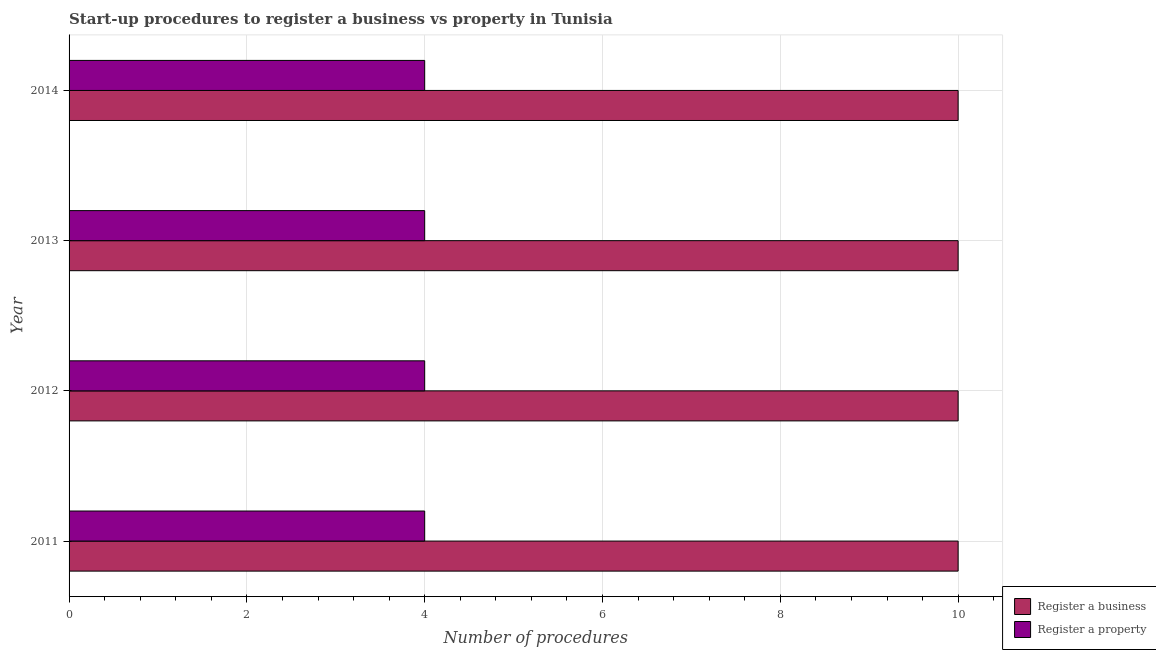Are the number of bars on each tick of the Y-axis equal?
Ensure brevity in your answer.  Yes. How many bars are there on the 3rd tick from the bottom?
Your answer should be compact. 2. In how many cases, is the number of bars for a given year not equal to the number of legend labels?
Ensure brevity in your answer.  0. What is the number of procedures to register a property in 2014?
Provide a short and direct response. 4. Across all years, what is the maximum number of procedures to register a business?
Give a very brief answer. 10. Across all years, what is the minimum number of procedures to register a property?
Offer a very short reply. 4. What is the total number of procedures to register a property in the graph?
Offer a very short reply. 16. What is the difference between the number of procedures to register a property in 2012 and the number of procedures to register a business in 2014?
Offer a very short reply. -6. Is the difference between the number of procedures to register a property in 2013 and 2014 greater than the difference between the number of procedures to register a business in 2013 and 2014?
Your answer should be compact. No. What is the difference between the highest and the lowest number of procedures to register a business?
Offer a terse response. 0. Is the sum of the number of procedures to register a property in 2012 and 2013 greater than the maximum number of procedures to register a business across all years?
Your answer should be compact. No. What does the 2nd bar from the top in 2014 represents?
Ensure brevity in your answer.  Register a business. What does the 2nd bar from the bottom in 2013 represents?
Your response must be concise. Register a property. How many bars are there?
Offer a terse response. 8. Are all the bars in the graph horizontal?
Your answer should be compact. Yes. How many years are there in the graph?
Your answer should be very brief. 4. What is the difference between two consecutive major ticks on the X-axis?
Your response must be concise. 2. Does the graph contain grids?
Give a very brief answer. Yes. How are the legend labels stacked?
Your response must be concise. Vertical. What is the title of the graph?
Your answer should be compact. Start-up procedures to register a business vs property in Tunisia. Does "Net National savings" appear as one of the legend labels in the graph?
Your answer should be compact. No. What is the label or title of the X-axis?
Your answer should be very brief. Number of procedures. What is the Number of procedures of Register a property in 2011?
Your response must be concise. 4. What is the Number of procedures in Register a property in 2012?
Your response must be concise. 4. What is the Number of procedures in Register a business in 2013?
Ensure brevity in your answer.  10. What is the Number of procedures of Register a property in 2014?
Your answer should be compact. 4. Across all years, what is the maximum Number of procedures of Register a property?
Provide a succinct answer. 4. Across all years, what is the minimum Number of procedures in Register a business?
Give a very brief answer. 10. Across all years, what is the minimum Number of procedures of Register a property?
Provide a succinct answer. 4. What is the total Number of procedures of Register a business in the graph?
Provide a succinct answer. 40. What is the total Number of procedures in Register a property in the graph?
Keep it short and to the point. 16. What is the difference between the Number of procedures of Register a property in 2011 and that in 2012?
Provide a short and direct response. 0. What is the difference between the Number of procedures in Register a business in 2011 and that in 2013?
Ensure brevity in your answer.  0. What is the difference between the Number of procedures in Register a property in 2011 and that in 2013?
Offer a very short reply. 0. What is the difference between the Number of procedures in Register a business in 2011 and that in 2014?
Provide a succinct answer. 0. What is the difference between the Number of procedures of Register a property in 2011 and that in 2014?
Keep it short and to the point. 0. What is the difference between the Number of procedures of Register a property in 2012 and that in 2014?
Provide a short and direct response. 0. What is the difference between the Number of procedures in Register a property in 2013 and that in 2014?
Make the answer very short. 0. What is the difference between the Number of procedures in Register a business in 2011 and the Number of procedures in Register a property in 2012?
Provide a short and direct response. 6. What is the difference between the Number of procedures of Register a business in 2011 and the Number of procedures of Register a property in 2014?
Offer a very short reply. 6. What is the difference between the Number of procedures in Register a business in 2012 and the Number of procedures in Register a property in 2014?
Ensure brevity in your answer.  6. What is the difference between the Number of procedures in Register a business in 2013 and the Number of procedures in Register a property in 2014?
Your response must be concise. 6. What is the average Number of procedures in Register a property per year?
Your answer should be very brief. 4. In the year 2012, what is the difference between the Number of procedures of Register a business and Number of procedures of Register a property?
Provide a succinct answer. 6. In the year 2014, what is the difference between the Number of procedures in Register a business and Number of procedures in Register a property?
Make the answer very short. 6. What is the ratio of the Number of procedures in Register a business in 2011 to that in 2012?
Ensure brevity in your answer.  1. What is the ratio of the Number of procedures of Register a property in 2011 to that in 2012?
Your answer should be very brief. 1. What is the ratio of the Number of procedures in Register a business in 2011 to that in 2013?
Provide a short and direct response. 1. What is the ratio of the Number of procedures in Register a business in 2012 to that in 2014?
Offer a terse response. 1. 